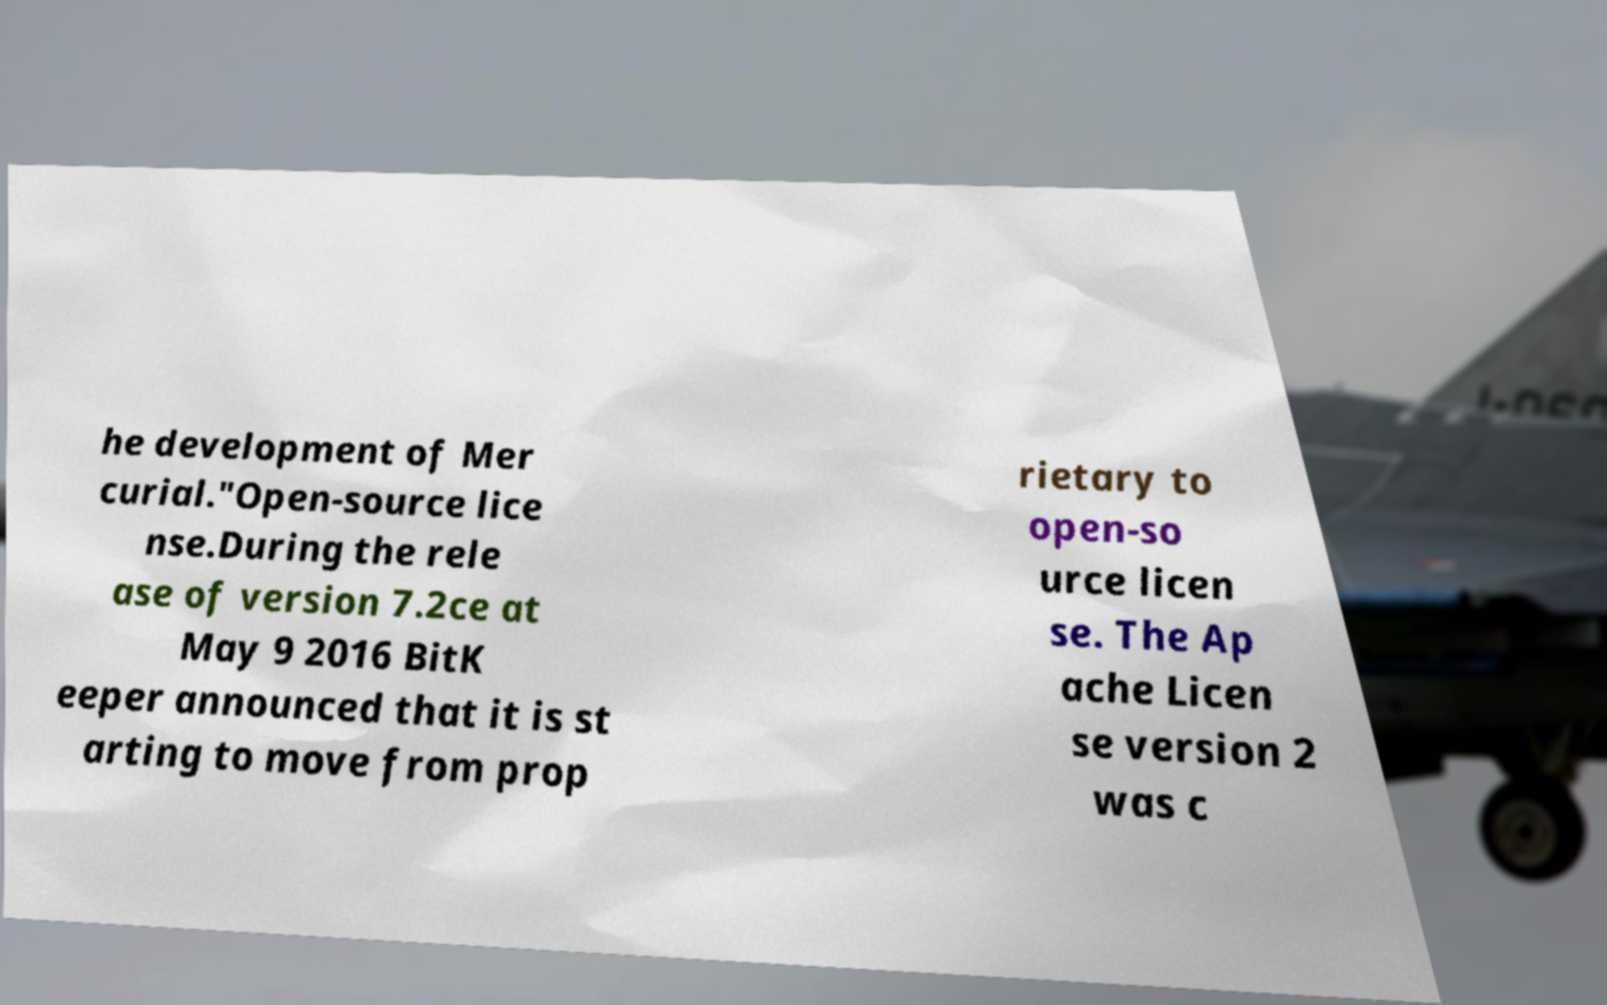Could you assist in decoding the text presented in this image and type it out clearly? he development of Mer curial."Open-source lice nse.During the rele ase of version 7.2ce at May 9 2016 BitK eeper announced that it is st arting to move from prop rietary to open-so urce licen se. The Ap ache Licen se version 2 was c 